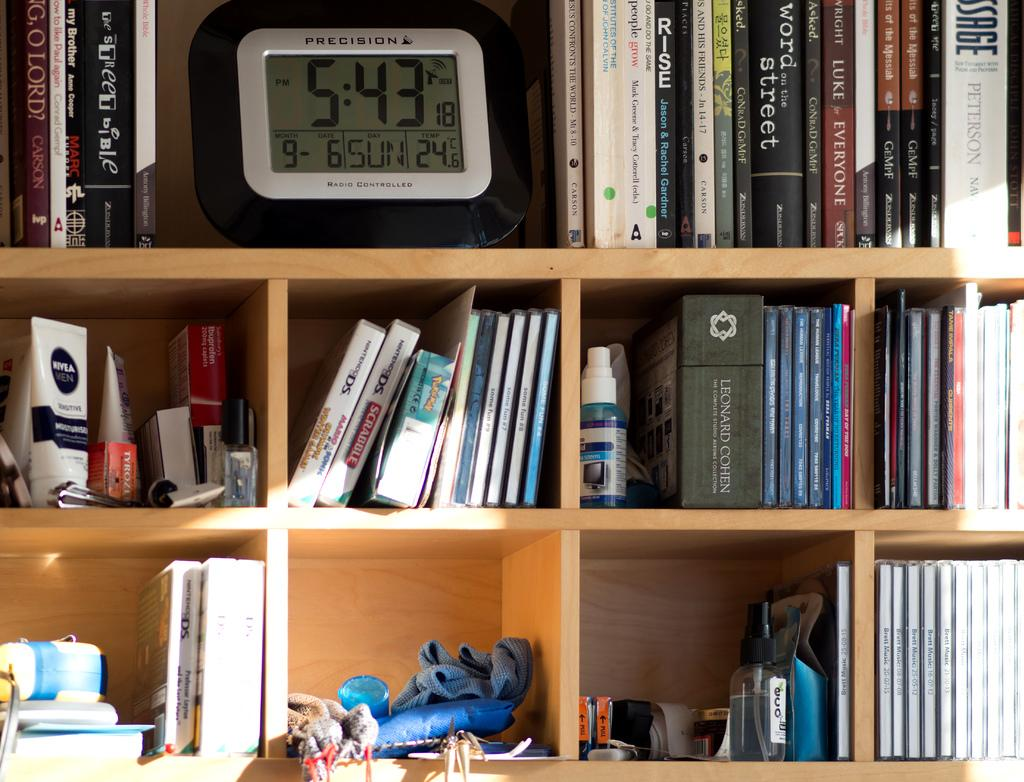<image>
Offer a succinct explanation of the picture presented. A radio controlled Precision clock on a shelf indicates the time. 